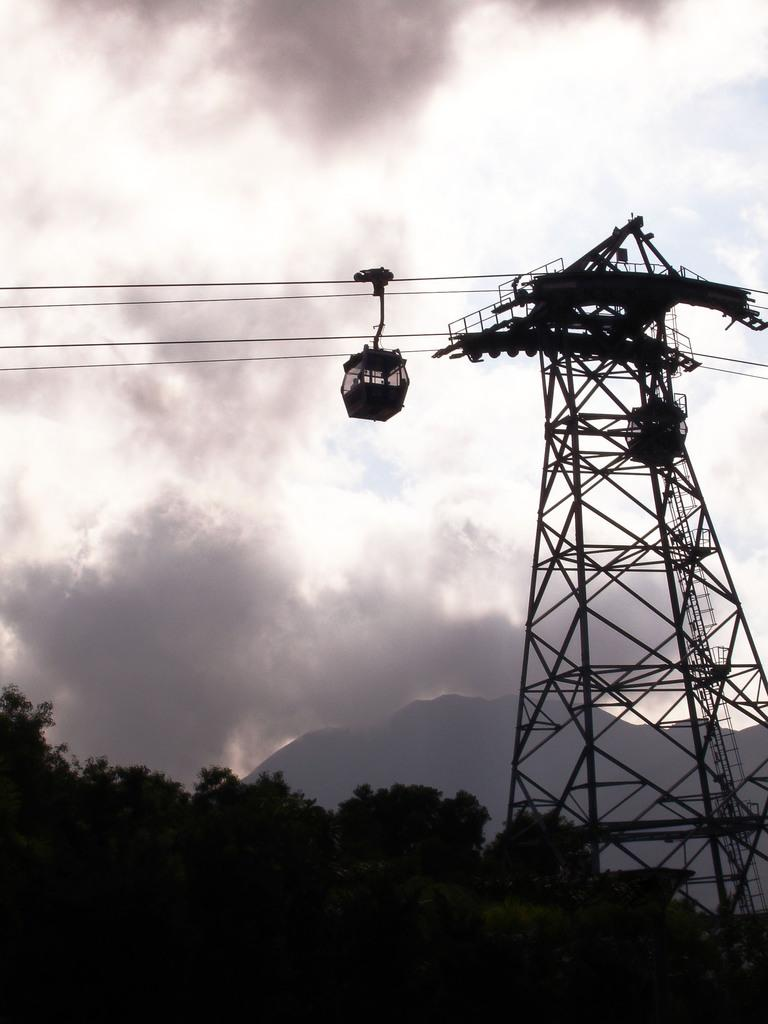What type of transportation system is depicted in the image? There is a rope-way in the image. What structure does the rope-way seem to be connected to? The rope-way appears to be connected to a transmission tower. What can be seen supporting the rope-way? There are cables visible in the image. What type of natural environment is present in the image? There are trees in the image. What is visible in the background of the image? The sky is visible in the background of the image. What color is the paint used on the shape in the image? There is no shape or paint present in the image; it features a rope-way, transmission tower, cables, trees, and the sky. 